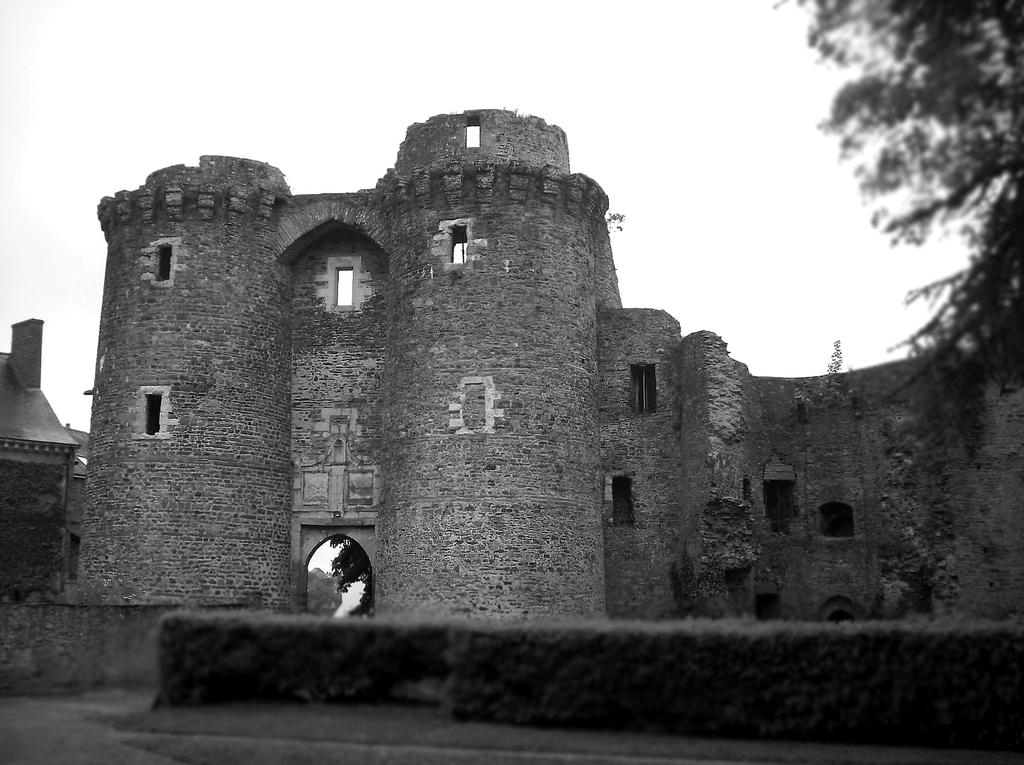What is the main structure in the center of the image? There is a fort in the center of the image. What type of vegetation can be seen on the right side of the image? There is a tree on the right side of the image. What can be seen in the background of the image? The sky is visible in the background of the image. What type of bells can be heard ringing in the image? There are no bells present in the image, and therefore no sound can be heard. 